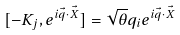<formula> <loc_0><loc_0><loc_500><loc_500>[ - K _ { j } , e ^ { i \vec { q } \cdot \vec { X } } ] = \sqrt { \theta } q _ { i } e ^ { i \vec { q } \cdot \vec { X } }</formula> 